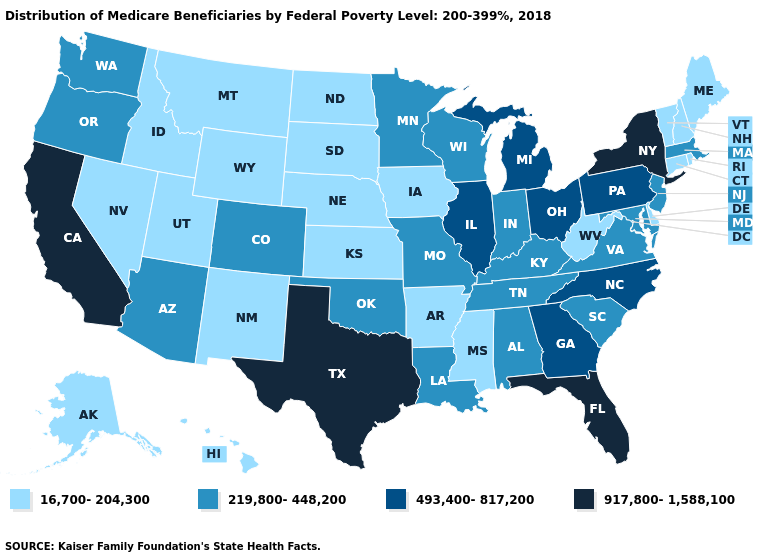Name the states that have a value in the range 219,800-448,200?
Answer briefly. Alabama, Arizona, Colorado, Indiana, Kentucky, Louisiana, Maryland, Massachusetts, Minnesota, Missouri, New Jersey, Oklahoma, Oregon, South Carolina, Tennessee, Virginia, Washington, Wisconsin. What is the lowest value in states that border Oklahoma?
Keep it brief. 16,700-204,300. Among the states that border California , which have the highest value?
Answer briefly. Arizona, Oregon. What is the highest value in states that border Arkansas?
Concise answer only. 917,800-1,588,100. Which states have the lowest value in the USA?
Keep it brief. Alaska, Arkansas, Connecticut, Delaware, Hawaii, Idaho, Iowa, Kansas, Maine, Mississippi, Montana, Nebraska, Nevada, New Hampshire, New Mexico, North Dakota, Rhode Island, South Dakota, Utah, Vermont, West Virginia, Wyoming. Does Colorado have the lowest value in the West?
Short answer required. No. Name the states that have a value in the range 16,700-204,300?
Answer briefly. Alaska, Arkansas, Connecticut, Delaware, Hawaii, Idaho, Iowa, Kansas, Maine, Mississippi, Montana, Nebraska, Nevada, New Hampshire, New Mexico, North Dakota, Rhode Island, South Dakota, Utah, Vermont, West Virginia, Wyoming. Among the states that border North Carolina , which have the lowest value?
Answer briefly. South Carolina, Tennessee, Virginia. What is the highest value in states that border Tennessee?
Answer briefly. 493,400-817,200. What is the value of Arizona?
Answer briefly. 219,800-448,200. What is the value of North Dakota?
Concise answer only. 16,700-204,300. What is the value of Kansas?
Be succinct. 16,700-204,300. What is the value of Wyoming?
Short answer required. 16,700-204,300. How many symbols are there in the legend?
Write a very short answer. 4. Does the first symbol in the legend represent the smallest category?
Concise answer only. Yes. 